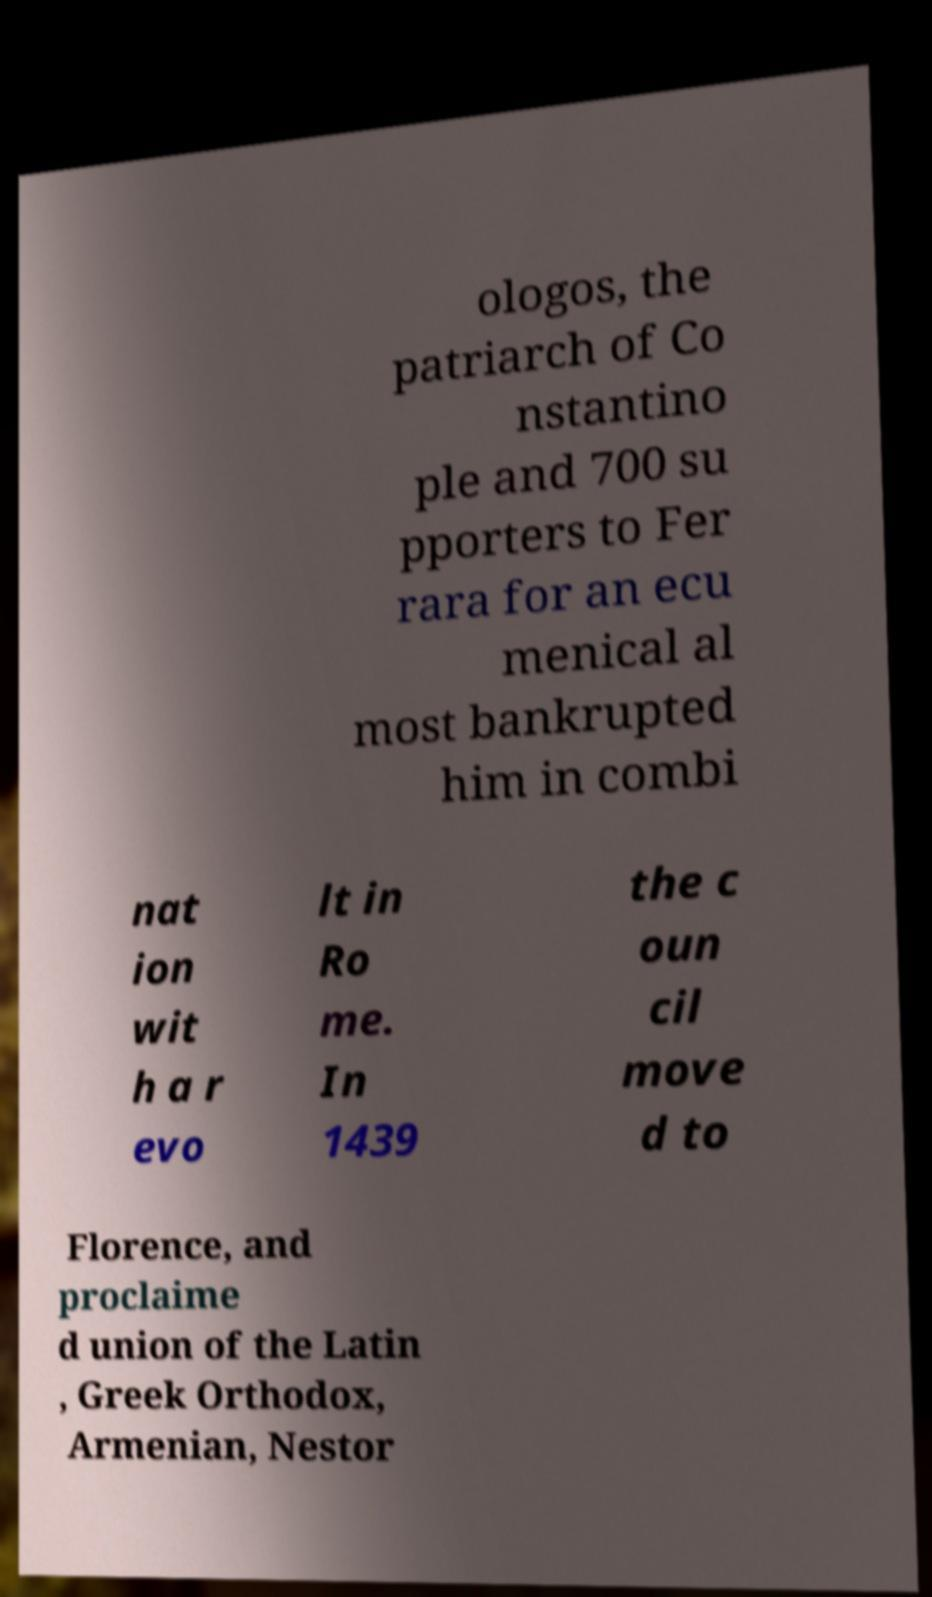Can you read and provide the text displayed in the image?This photo seems to have some interesting text. Can you extract and type it out for me? ologos, the patriarch of Co nstantino ple and 700 su pporters to Fer rara for an ecu menical al most bankrupted him in combi nat ion wit h a r evo lt in Ro me. In 1439 the c oun cil move d to Florence, and proclaime d union of the Latin , Greek Orthodox, Armenian, Nestor 